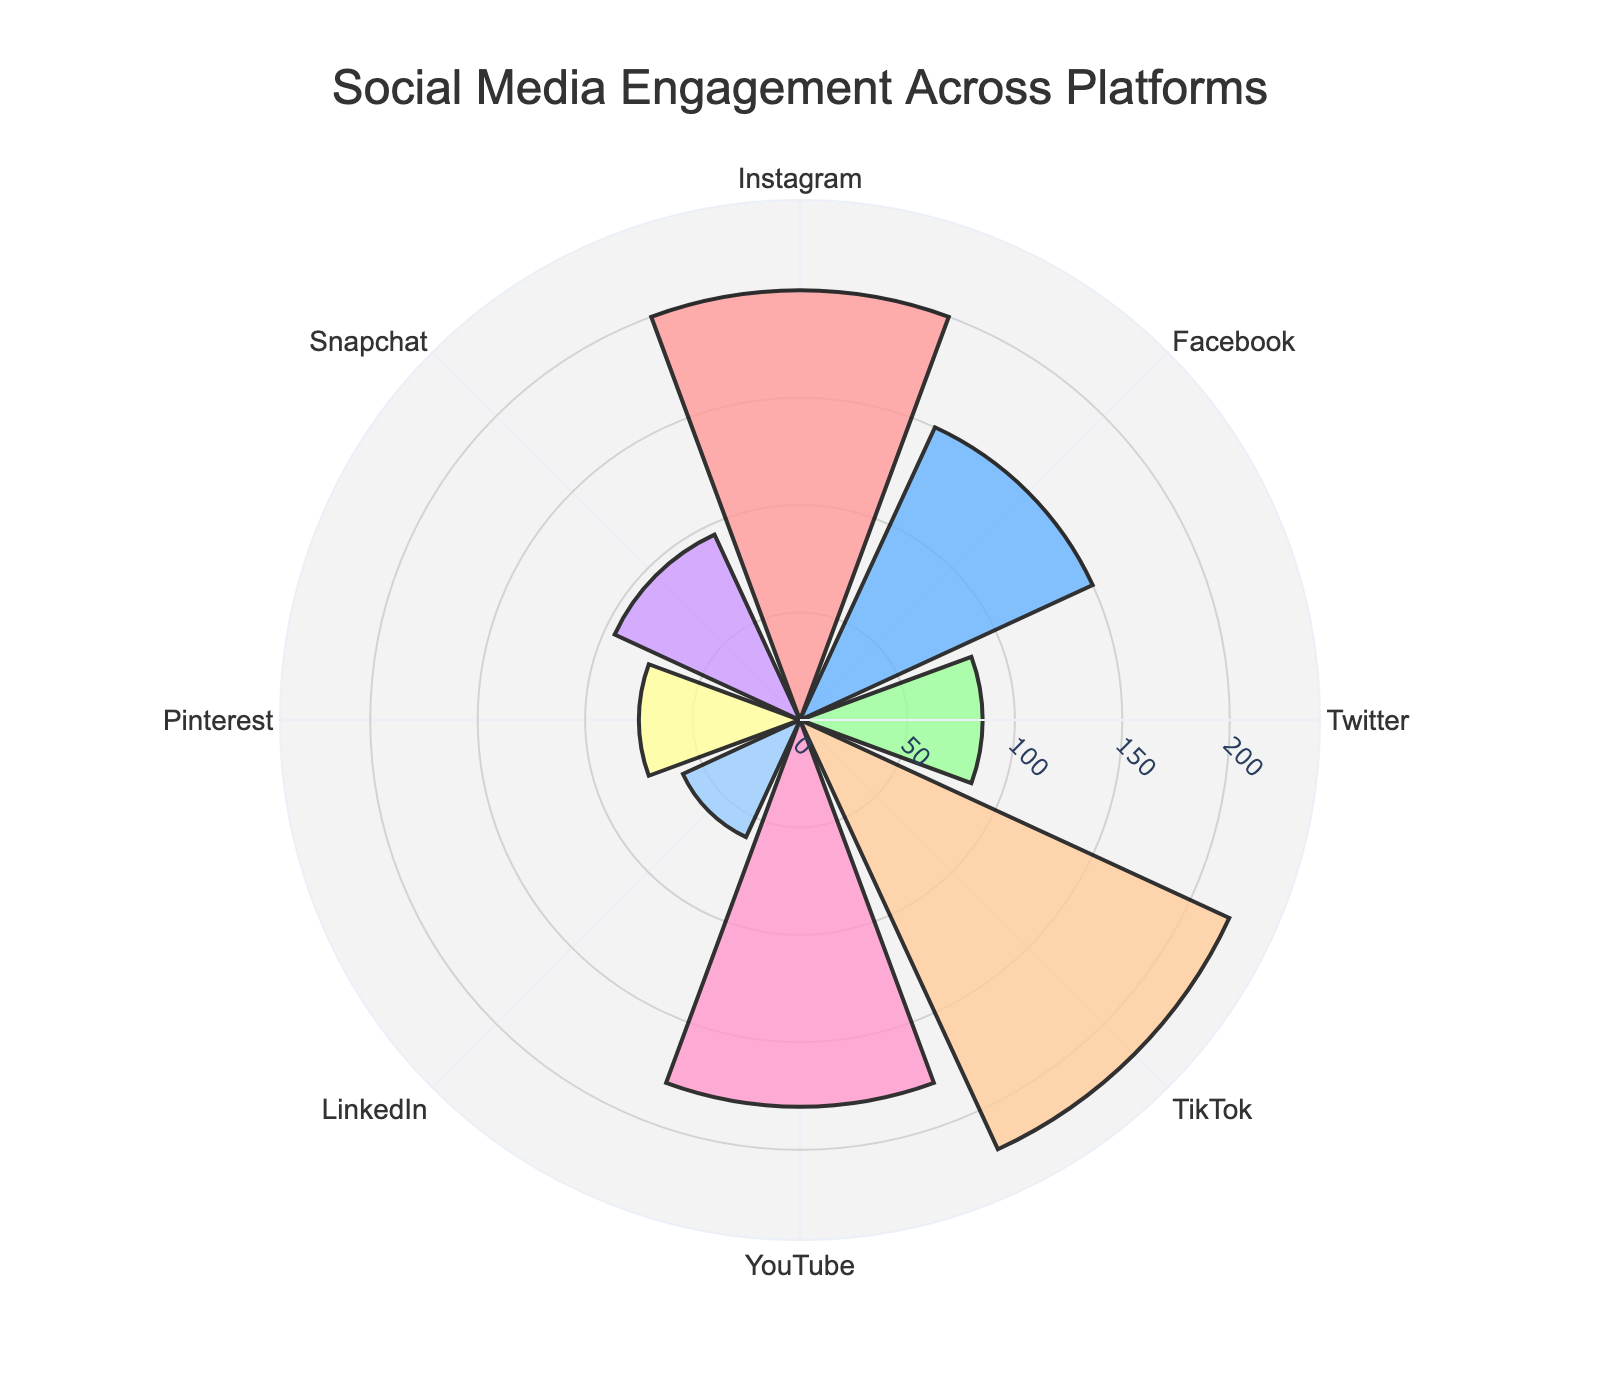What is the title of the chart? The title of the chart is displayed prominently at the top center of the figure. It provides a summary of what the chart depicts. In this case, the title reads "Social Media Engagement Across Platforms".
Answer: Social Media Engagement Across Platforms Which platform has the highest engagement per post? By observing the lengths of the bars in the rose chart, we see that the bar for TikTok stretches the furthest from the center, indicating the highest engagement per post.
Answer: TikTok How many platforms have an engagement per post greater than 100? To determine this, visually identify and count the platforms whose bars extend beyond the 100-mark on the radial axis. The platforms are Instagram, Facebook, TikTok, and YouTube.
Answer: 4 What is the difference in engagements per post between the highest and lowest platforms? Calculate the difference by subtracting the smallest value (LinkedIn, 60) from the largest value (TikTok, 220).
Answer: 160 Which platform's engagement per post is closest to 100? By comparing the lengths of the bars around the 100-mark on the radial axis, identify the closest one. Snapchat's bar is closest to the 100-mark with a value of 95.
Answer: Snapchat What is the average engagement per post across all platforms? Sum up all the engagement values (200 + 150 + 85 + 220 + 180 + 60 + 75 + 95 = 1065), then divide by the number of platforms (8): 1065 / 8 = 133.125.
Answer: 133.125 Which platform has the second highest engagements per post? By ranking the lengths of the bars, identify the second longest which is for Instagram with an engagement per post value of 200.
Answer: Instagram Is the engagement per post for YouTube greater than the engagement per post for Facebook? Compare the bar lengths for YouTube and Facebook. YouTube's bar (180) is longer than Facebook's bar (150).
Answer: Yes Which platform has an engagement per post value closest to the average engagement per post? Calculate the average engagement per post (133.125) and compare it to the values. Facebook (150) is closest to the average.
Answer: Facebook What is the combined engagement per post for LinkedIn, Pinterest, and Snapchat? Add the engagement values for LinkedIn (60), Pinterest (75), and Snapchat (95): 60 + 75 + 95 = 230.
Answer: 230 